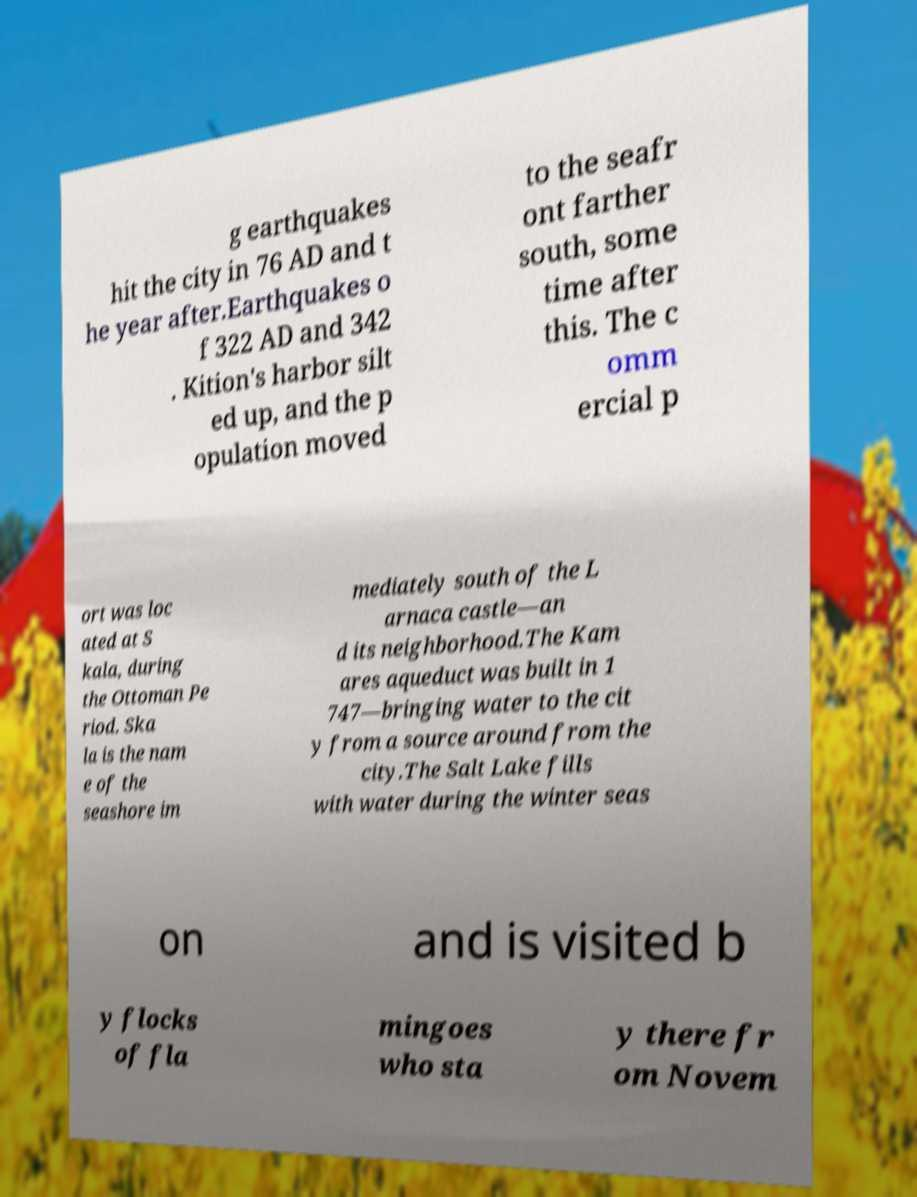Could you assist in decoding the text presented in this image and type it out clearly? g earthquakes hit the city in 76 AD and t he year after.Earthquakes o f 322 AD and 342 . Kition's harbor silt ed up, and the p opulation moved to the seafr ont farther south, some time after this. The c omm ercial p ort was loc ated at S kala, during the Ottoman Pe riod. Ska la is the nam e of the seashore im mediately south of the L arnaca castle—an d its neighborhood.The Kam ares aqueduct was built in 1 747—bringing water to the cit y from a source around from the city.The Salt Lake fills with water during the winter seas on and is visited b y flocks of fla mingoes who sta y there fr om Novem 